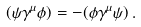Convert formula to latex. <formula><loc_0><loc_0><loc_500><loc_500>( \psi \gamma ^ { \mu } \phi ) = - ( \phi \gamma ^ { \mu } \psi ) \, .</formula> 